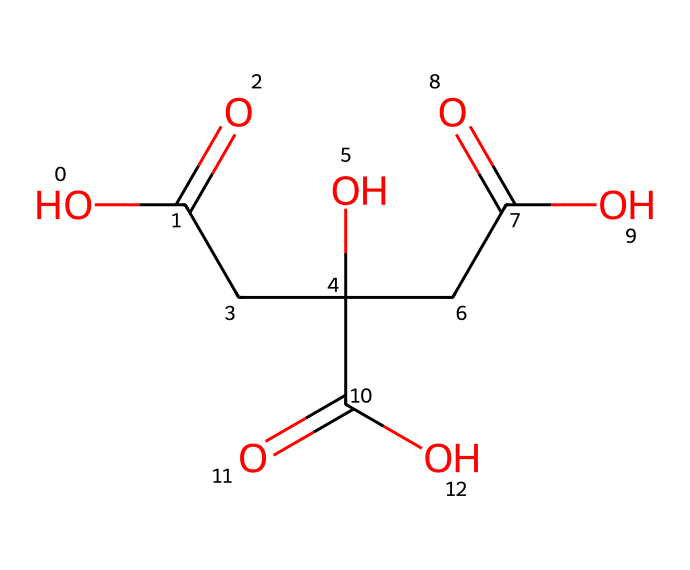how many carbon atoms are present in the chemical? By examining the SMILES representation, we can count the carbon atoms (C). The structure has five instances of carbon which can be identified at various points in the SMILES notation.
Answer: five what is the primary function of this chemical? Citric acid is commonly known for its ability to act as a chelating agent, helping to bind and remove rust stains from surfaces due to its acidic properties.
Answer: rust removal how many carboxylic acid groups are present? The SMILES representation contains three occurrences of the carboxylic acid group (-COOH) indicated by the multiple 'C(=O)O' sections. Counting these gives us three.
Answer: three what is the pH of a typical solution of this acid? Citric acid typically has a pH around 2 to 3 when dissolved in water, signifying its strong acidic nature.
Answer: two to three what type of acid is citric acid classified as? Citric acid is classified as a weak organic acid due to its ability to partially dissociate in solution, contrasting with strong acids that fully dissociate.
Answer: weak acid why is citric acid preferred over stronger acids for rust removal? Citric acid is less corrosive and safer to use on delicate surfaces, making it a preferable choice for cleaning historical artifacts like Civil War weaponry, as it minimizes damage while effectively removing rust.
Answer: safer choice 